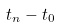<formula> <loc_0><loc_0><loc_500><loc_500>t _ { n } - t _ { 0 }</formula> 